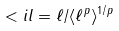Convert formula to latex. <formula><loc_0><loc_0><loc_500><loc_500>< i l = \ell / \langle \ell ^ { p } \rangle ^ { 1 / p } \,</formula> 